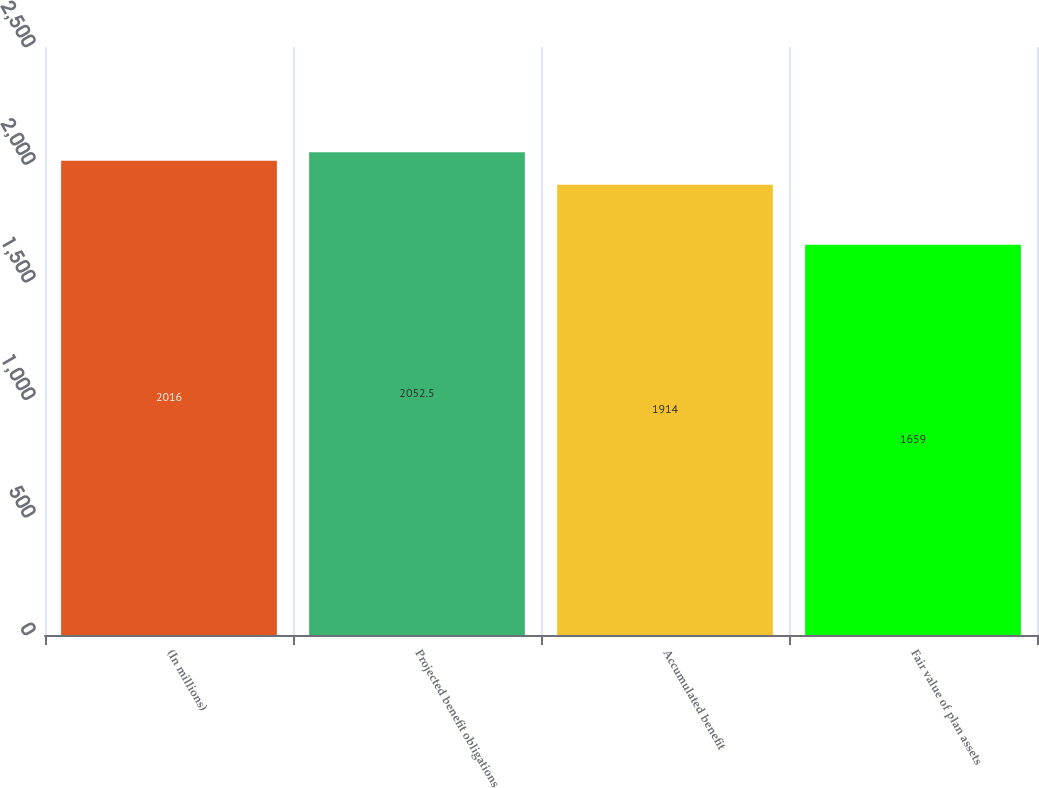Convert chart to OTSL. <chart><loc_0><loc_0><loc_500><loc_500><bar_chart><fcel>(In millions)<fcel>Projected benefit obligations<fcel>Accumulated benefit<fcel>Fair value of plan assets<nl><fcel>2016<fcel>2052.5<fcel>1914<fcel>1659<nl></chart> 